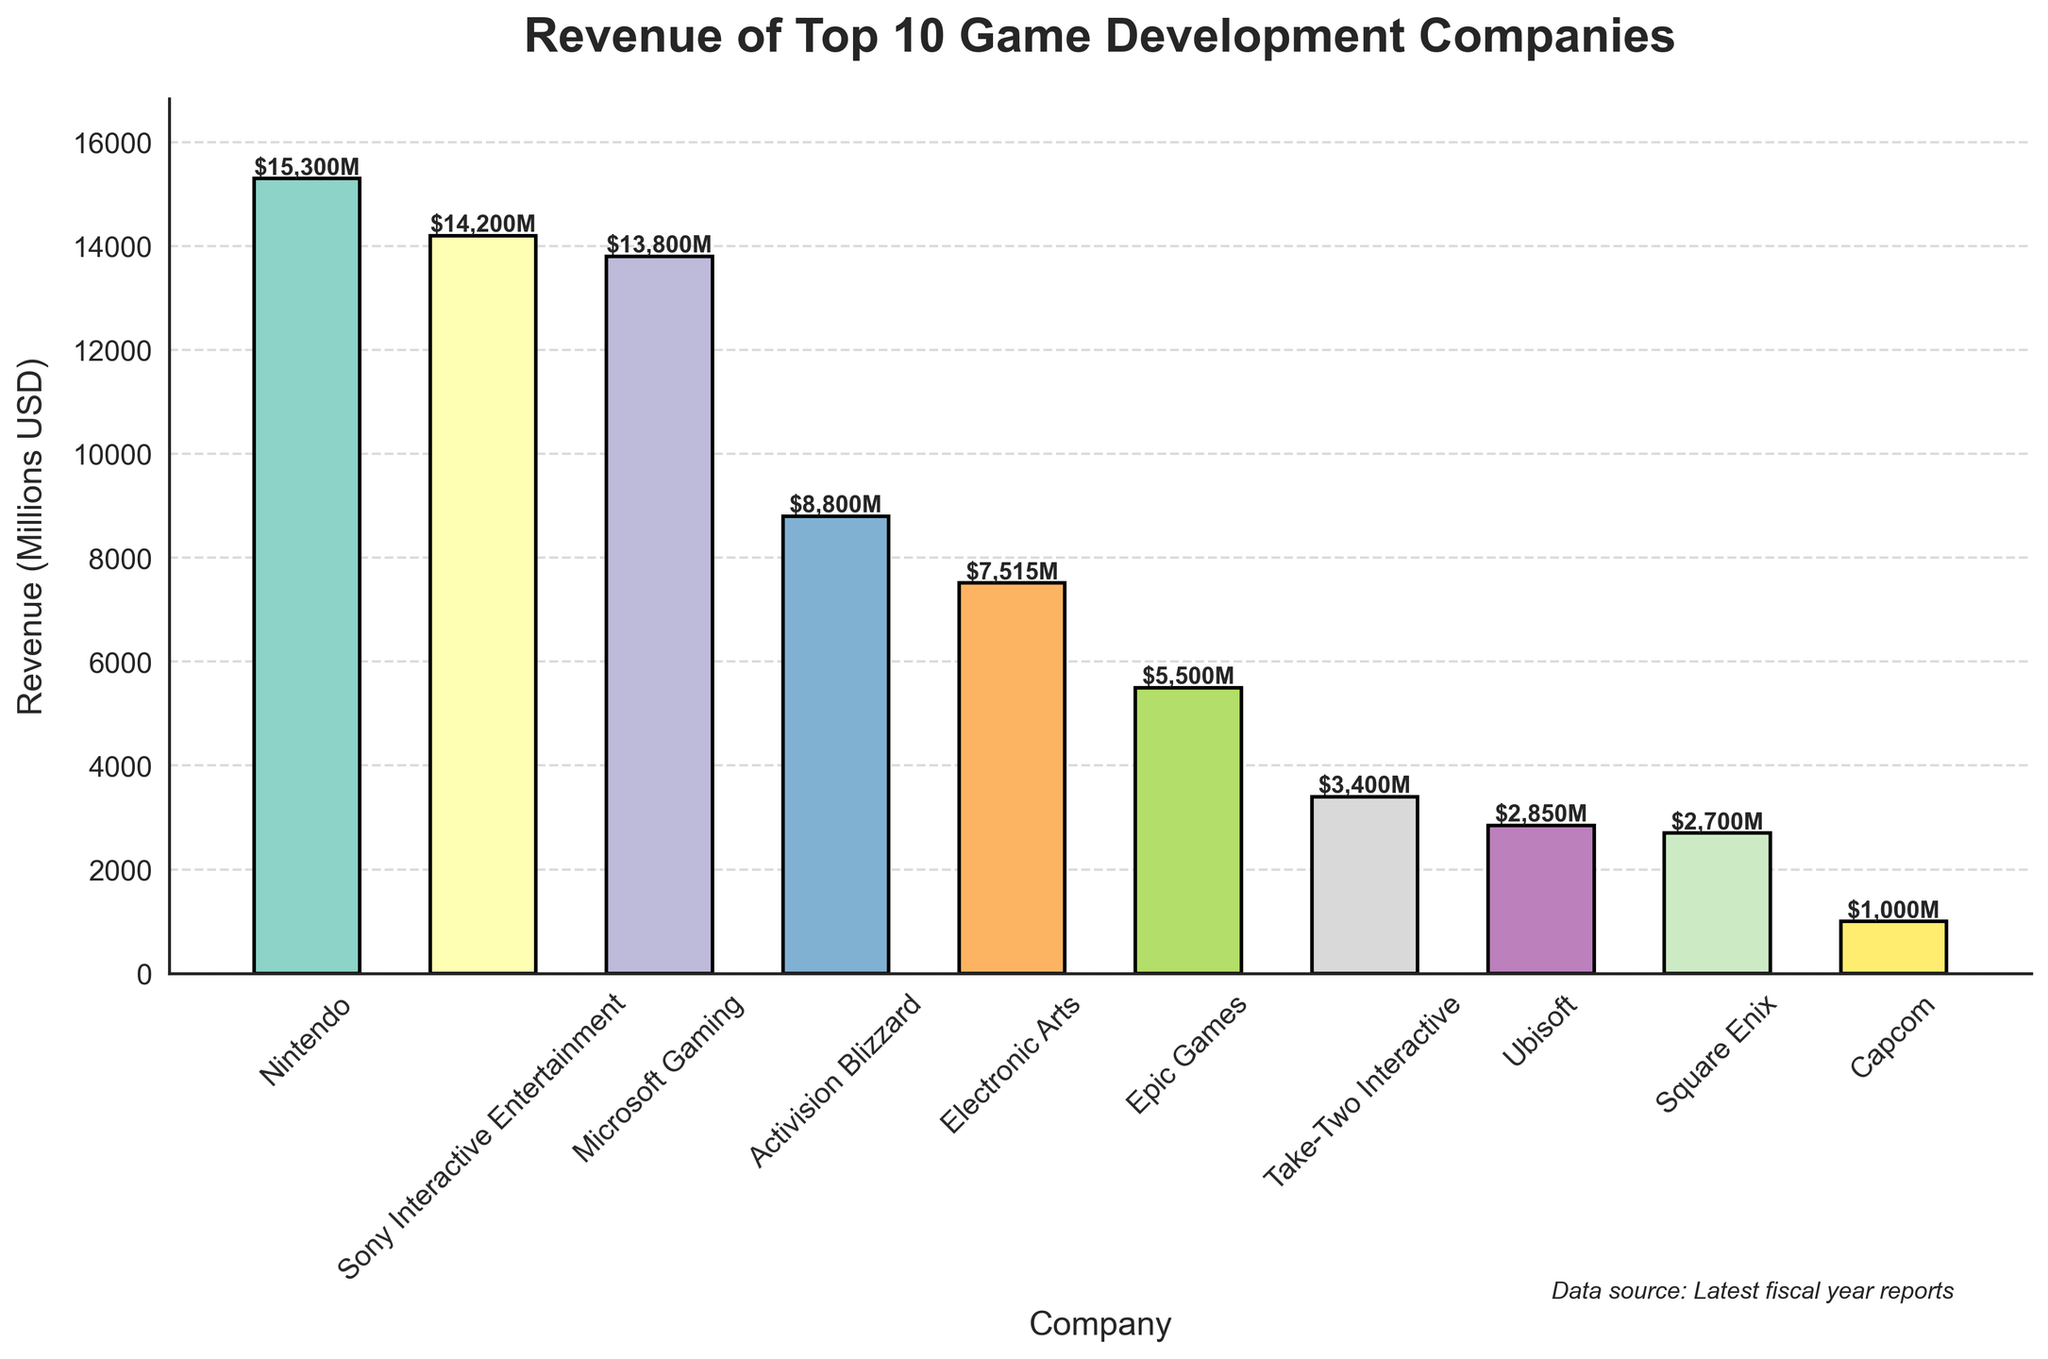Which company has the highest revenue? By looking at the height of the bar, Nintendo has the tallest bar, indicating it has the highest revenue among the listed companies at $15,300 million.
Answer: Nintendo What is the combined revenue of the companies Microsoft Gaming and Sony Interactive Entertainment? The revenue of Microsoft Gaming is $13,800 million and Sony Interactive Entertainment is $14,200 million. Adding them up: $13,800 million + $14,200 million = $28,000 million.
Answer: $28,000M Which company has the lowest revenue, and what is its value? The company with the shortest bar in the figure is Capcom, showing a revenue of $1,000 million.
Answer: Capcom, $1,000M How much more revenue does Nintendo have compared to Epic Games? Nintendo has a revenue of $15,300 million and Epic Games has $5,500 million. The difference is $15,300 million - $5,500 million = $9,800 million.
Answer: $9,800M What is the average revenue of all the companies listed in the figure? Sum all revenues: $15,300 + $14,200 + $13,800 + $8,800 + $7,515 + $5,500 + $3,400 + $2,850 + $2,700 + $1,000 = $75,065 million. There are 10 companies, so the average is $75,065 million / 10 = $7,506.5 million.
Answer: $7,506.5M Which companies fall below the average revenue? The average revenue is $7,506.5 million. The companies with revenues below this average are: Activision Blizzard ($8,800), Electronic Arts ($7,515), Epic Games ($5,500), Take-Two Interactive ($3,400), Ubisoft ($2,850), Square Enix ($2,700), Capcom ($1,000).
Answer: Electronic Arts, Epic Games, Take-Two Interactive, Ubisoft, Square Enix, Capcom Which company has a revenue of about half of Sony Interactive Entertainment’s revenue? Sony Interactive Entertainment's revenue is $14,200 million. Half of this value is approximately $7,100 million. The closest company to this value is Electronic Arts with $7,515 million.
Answer: Electronic Arts Compare the revenue difference between the largest and the smallest companies. The largest company, Nintendo, has a revenue of $15,300 million and the smallest company, Capcom, has $1,000 million. The difference is $15,300 million - $1,000 million = $14,300 million.
Answer: $14,300M 